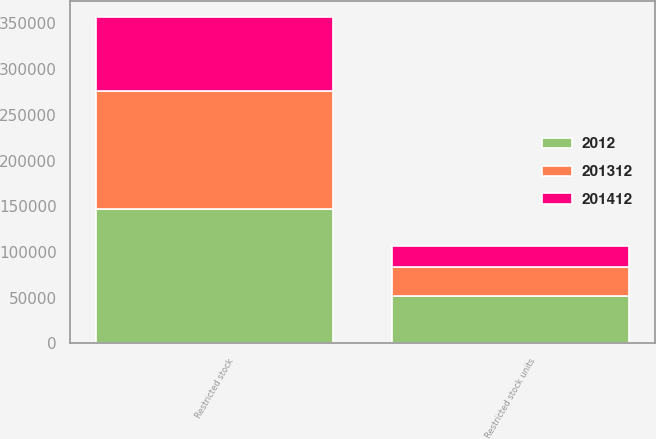Convert chart to OTSL. <chart><loc_0><loc_0><loc_500><loc_500><stacked_bar_chart><ecel><fcel>Restricted stock<fcel>Restricted stock units<nl><fcel>2012<fcel>147221<fcel>52000<nl><fcel>201312<fcel>128923<fcel>32000<nl><fcel>201412<fcel>80460<fcel>22000<nl></chart> 